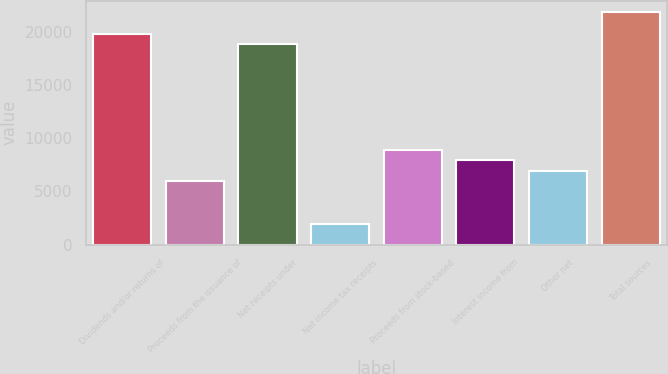Convert chart. <chart><loc_0><loc_0><loc_500><loc_500><bar_chart><fcel>Dividends and/or returns of<fcel>Proceeds from the issuance of<fcel>Net receipts under<fcel>Net income tax receipts<fcel>Proceeds from stock-based<fcel>Interest income from<fcel>Other net<fcel>Total sources<nl><fcel>19817.6<fcel>5945.59<fcel>18826.8<fcel>1982.15<fcel>8918.17<fcel>7927.31<fcel>6936.45<fcel>21799.3<nl></chart> 